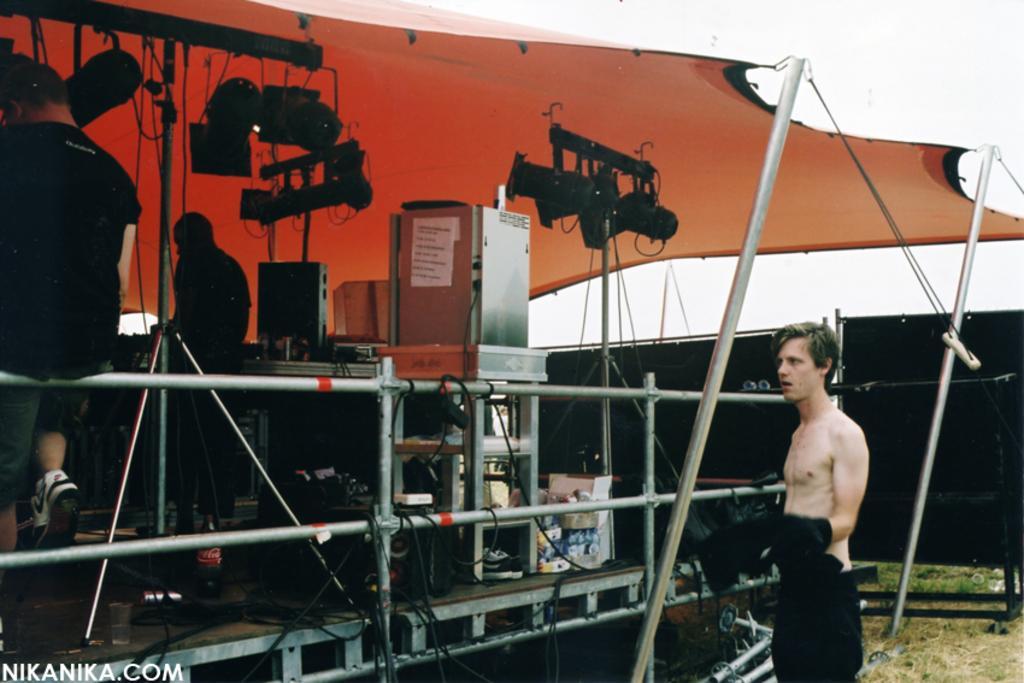In one or two sentences, can you explain what this image depicts? In this image, we can see persons, lights and some objects on the stage. There is a tent at the top of the image. There is an another person in the bottom right of the image. 